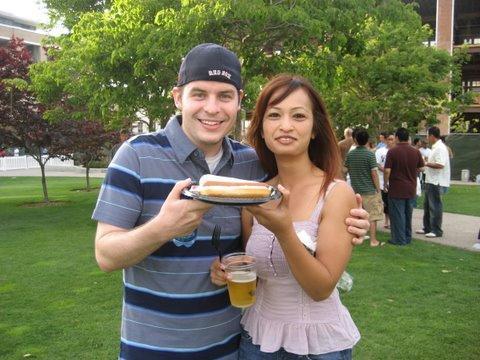How many people are there?
Give a very brief answer. 5. 